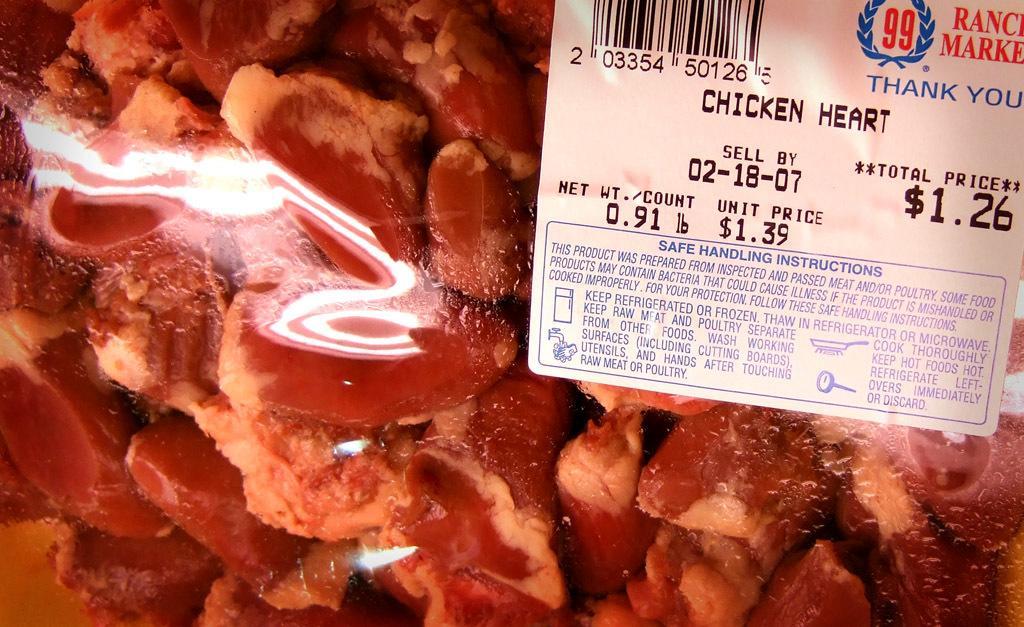Could you give a brief overview of what you see in this image? In this image I can see number of meat pieces in a plastic cover and on the right side of this image I can see a white colour label. I can also see something is written on the label. 